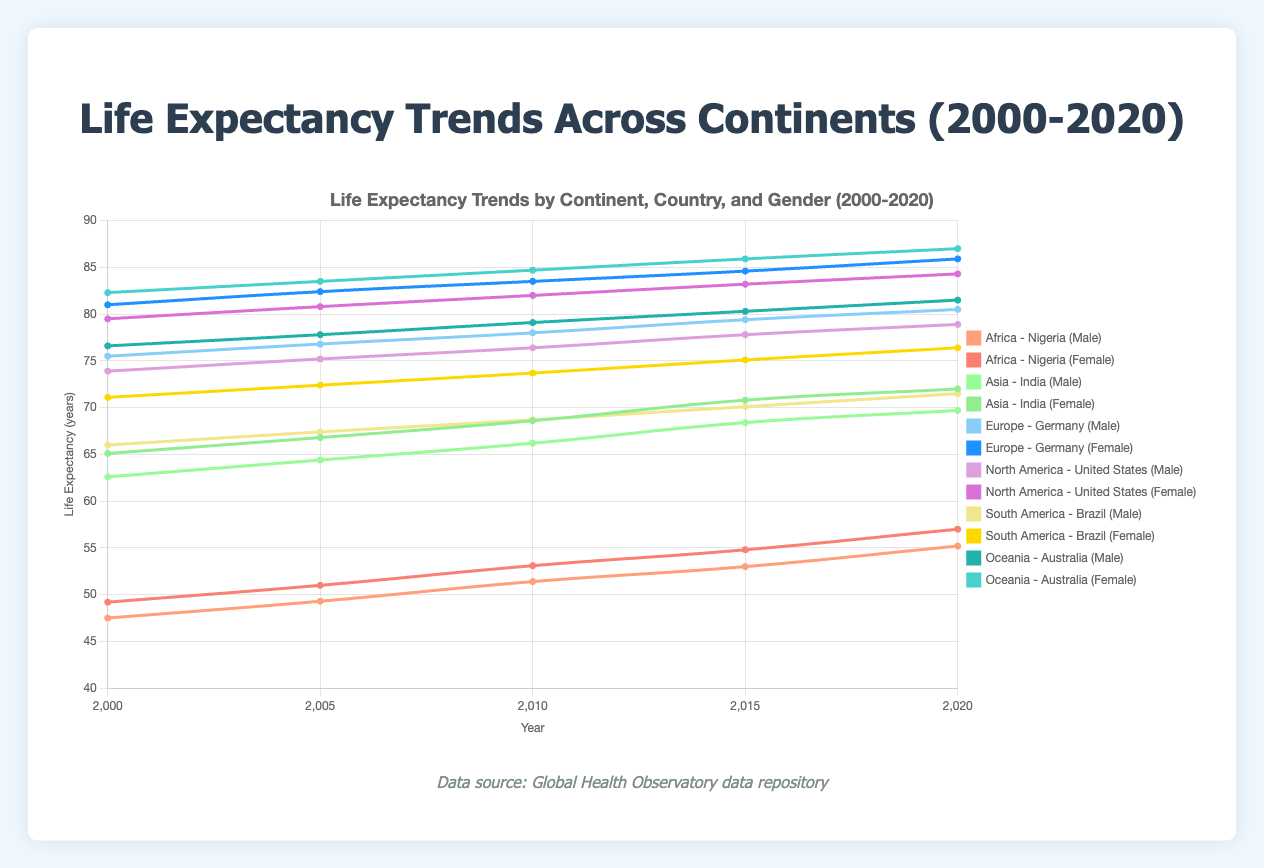What is the overall trend in life expectancy for males in Australia from 2000 to 2020? The data points for males in Australia are (2000: 76.6), (2005: 77.8), (2010: 79.1), (2015: 80.3), and (2020: 81.5). Observing these, we notice a steady increase in life expectancy over the years.
Answer: Steady increase Which continent experienced a greater increase in female life expectancy from 2000 to 2020: Africa or South America? For Africa (Nigeria), female life expectancy increased from 49.2 (2000) to 57.0 (2020), a total increase of 7.8 years. For South America (Brazil), female life expectancy increased from 71.1 (2000) to 76.4 (2020), a total increase of 5.3 years. Therefore, Africa experienced a greater increase.
Answer: Africa Compare the life expectancy of males in Germany and the United States in 2005. Which country had a higher life expectancy, and by how much? In 2005, the life expectancy for males in Germany was 76.8 years, whereas in the United States it was 75.2 years. Germany had a higher life expectancy. The difference is 76.8 - 75.2 = 1.6 years.
Answer: Germany, 1.6 years What is the average life expectancy for females in India over the years 2000, 2005, and 2010? Life expectancy for females in India for each year: 2000: 65.1, 2005: 66.8, and 2010: 68.6. The average is calculated as (65.1 + 66.8 + 68.6) / 3 = 66.83 years.
Answer: 66.83 Between 2005 and 2010, which country showed a more significant increase in male life expectancy: Nigeria or Brazil? For Nigeria, the increase from 2005 (49.3) to 2010 (51.4) is 51.4 - 49.3 = 2.1 years. For Brazil, the increase from 2005 (67.4) to 2010 (68.7) is 68.7 - 67.4 = 1.3 years. Therefore, Nigeria showed a more significant increase.
Answer: Nigeria Which continent shows the greatest disparity between male and female life expectancy in 2020? In 2020, the life expectancy disparity between genders for each continent is: Africa (Nigeria) = 57.0 - 55.2 = 1.8 years, Asia (India) = 72.0 - 69.7 = 2.3 years, Europe (Germany) = 85.9 - 80.5 = 5.4 years, North America (USA) = 84.3 - 78.9 = 5.4 years, South America (Brazil) = 76.4 - 71.5 = 4.9 years, and Oceania (Australia) = 87.0 - 81.5 = 5.5 years. Oceania shows the greatest disparity.
Answer: Oceania What is the color representation for male and female data points in Europe? The color for males in Europe (Germany) is blue, and for females, it is a darker shade of blue.
Answer: Blue, darker blue 